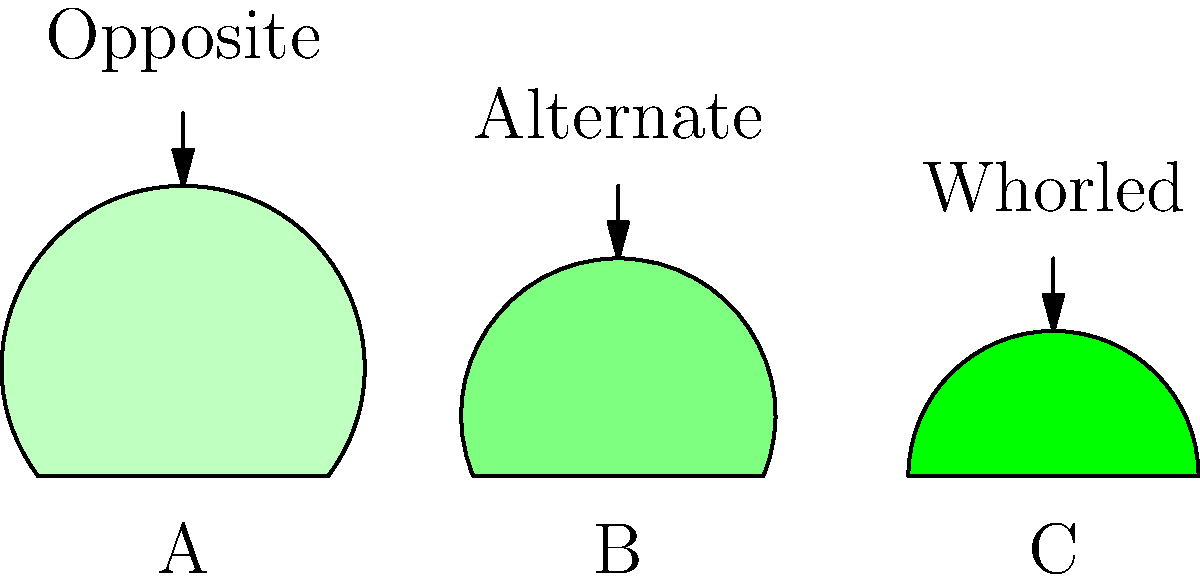As a hiking club founder, you often encounter various tree species during your excursions. Based on the leaf shapes and arrangements shown in the diagram, which leaf shape and arrangement is most likely to belong to a maple tree? To identify the leaf shape and arrangement most likely belonging to a maple tree, let's analyze the given information step-by-step:

1. Leaf shapes:
   A: Broad, with pointed lobes
   B: Oval-shaped, with a smooth edge
   C: Narrow, with a pointed tip

2. Leaf arrangements:
   A: Opposite
   B: Alternate
   C: Whorled

3. Maple tree characteristics:
   - Maple leaves typically have broad, palmate shapes with distinct lobes.
   - Maple leaves are arranged in opposite pairs along the branches.

4. Comparing the options:
   A: Broad leaf with pointed lobes and opposite arrangement
   B: Oval leaf with smooth edge and alternate arrangement
   C: Narrow leaf with pointed tip and whorled arrangement

5. Conclusion:
   Leaf A most closely resembles a maple leaf due to its broad shape with pointed lobes and opposite arrangement.
Answer: A (Broad leaf with opposite arrangement) 